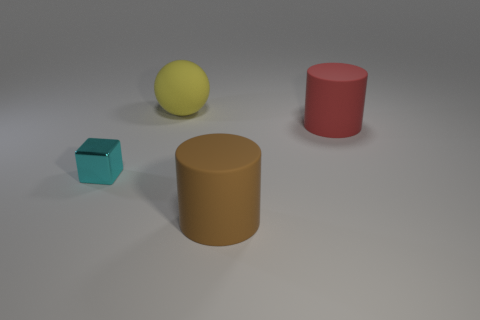Can you describe the objects in the image based on their color and shape? Certainly! The image displays four objects with distinct colors and shapes. On the left, there's a turquoise cube and in front of it, a large ochre cylinder. To the right, we see a smaller red cylinder, and further right, a yellow sphere with a matte surface rests on the plane. How do the objects compare in size to each other? The turquoise cube appears to be the smallest object. The red cylinder is taller but with a smaller diameter compared to the cube. The ochre cylinder is the largest in both height and diameter. Lastly, the yellow sphere's size falls between the red cylinder and the ochre cylinder in terms of volume. 